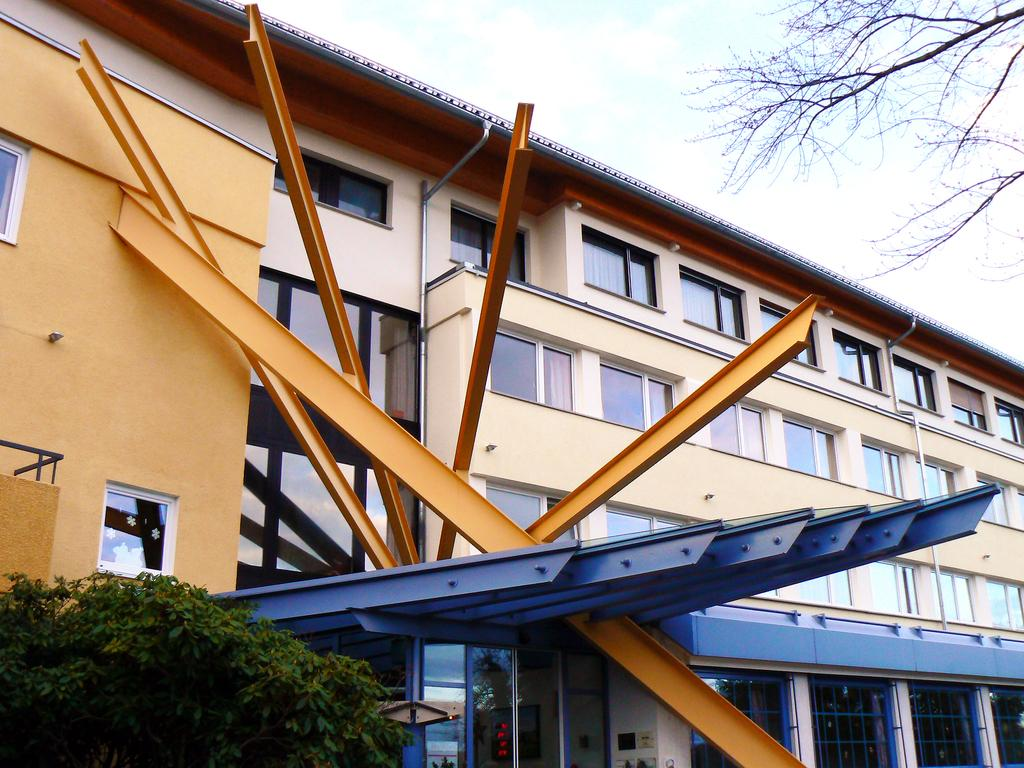What type of structure is depicted in the image? There is an architectural building in the image. What can be seen at the top of the image? There is a tree at the top of the image, and the sky is also visible. Are there any other trees visible in the image? Yes, there is another tree in the bottom left corner of the image. How many rings are being worn by the expert in the image? There is no expert or rings present in the image. What type of ants can be seen crawling on the building in the image? There are no ants visible in the image; it features an architectural building, a tree, and the sky. 